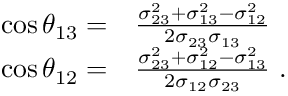Convert formula to latex. <formula><loc_0><loc_0><loc_500><loc_500>\begin{array} { r l } { \cos \theta _ { 1 3 } = } & \frac { \sigma _ { 2 3 } ^ { 2 } + \sigma _ { 1 3 } ^ { 2 } - \sigma _ { 1 2 } ^ { 2 } } { 2 \sigma _ { 2 3 } \sigma _ { 1 3 } } } \\ { \cos \theta _ { 1 2 } = } & \frac { \sigma _ { 2 3 } ^ { 2 } + \sigma _ { 1 2 } ^ { 2 } - \sigma _ { 1 3 } ^ { 2 } } { 2 \sigma _ { 1 2 } \sigma _ { 2 3 } } . } \end{array}</formula> 